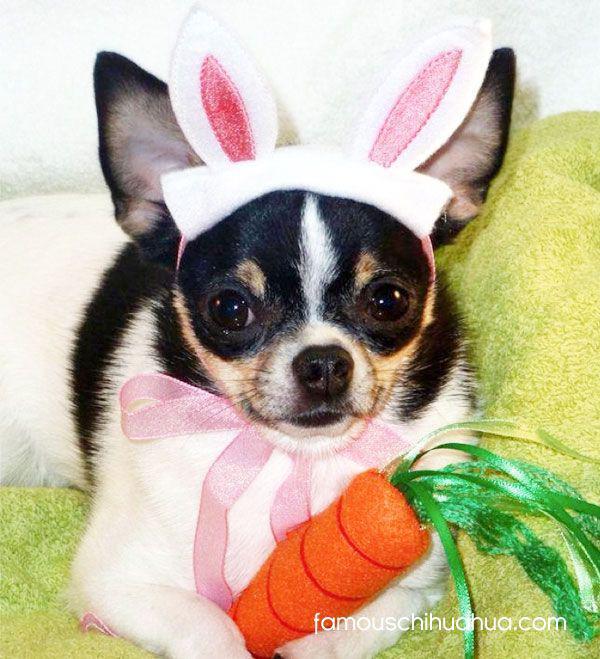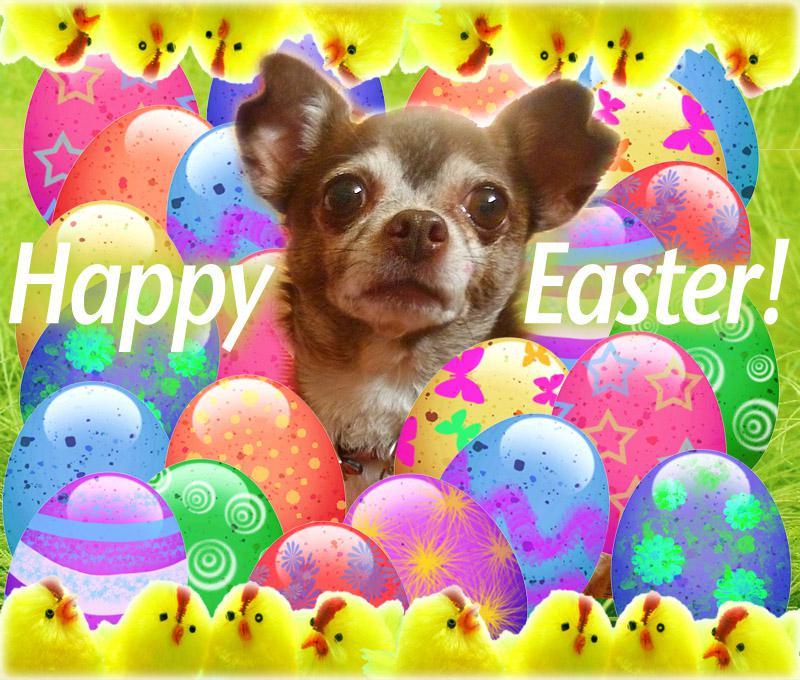The first image is the image on the left, the second image is the image on the right. Given the left and right images, does the statement "The left image has a carrot." hold true? Answer yes or no. Yes. The first image is the image on the left, the second image is the image on the right. Examine the images to the left and right. Is the description "A dog has an orange carrot in an image that includes bunny ears." accurate? Answer yes or no. Yes. 